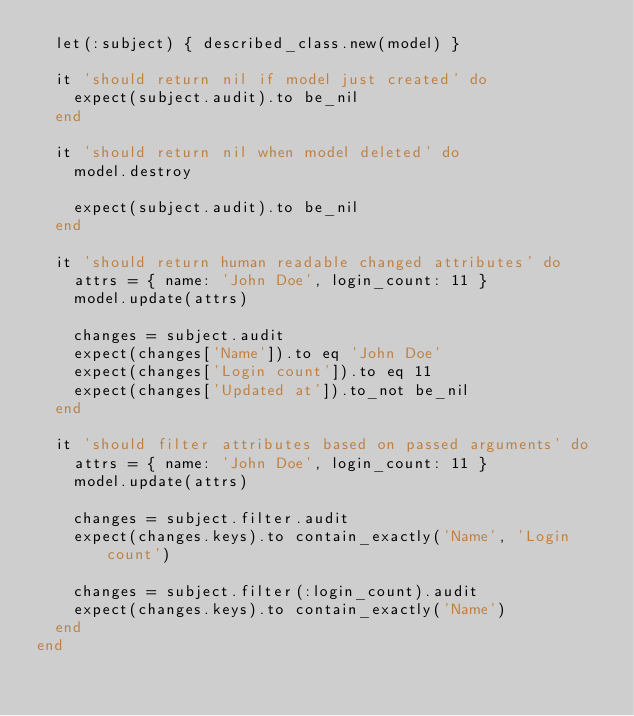Convert code to text. <code><loc_0><loc_0><loc_500><loc_500><_Ruby_>  let(:subject) { described_class.new(model) }

  it 'should return nil if model just created' do
    expect(subject.audit).to be_nil
  end

  it 'should return nil when model deleted' do
    model.destroy

    expect(subject.audit).to be_nil
  end

  it 'should return human readable changed attributes' do
    attrs = { name: 'John Doe', login_count: 11 }
    model.update(attrs)

    changes = subject.audit
    expect(changes['Name']).to eq 'John Doe'
    expect(changes['Login count']).to eq 11
    expect(changes['Updated at']).to_not be_nil
  end

  it 'should filter attributes based on passed arguments' do
    attrs = { name: 'John Doe', login_count: 11 }
    model.update(attrs)

    changes = subject.filter.audit
    expect(changes.keys).to contain_exactly('Name', 'Login count')

    changes = subject.filter(:login_count).audit
    expect(changes.keys).to contain_exactly('Name')
  end
end
</code> 